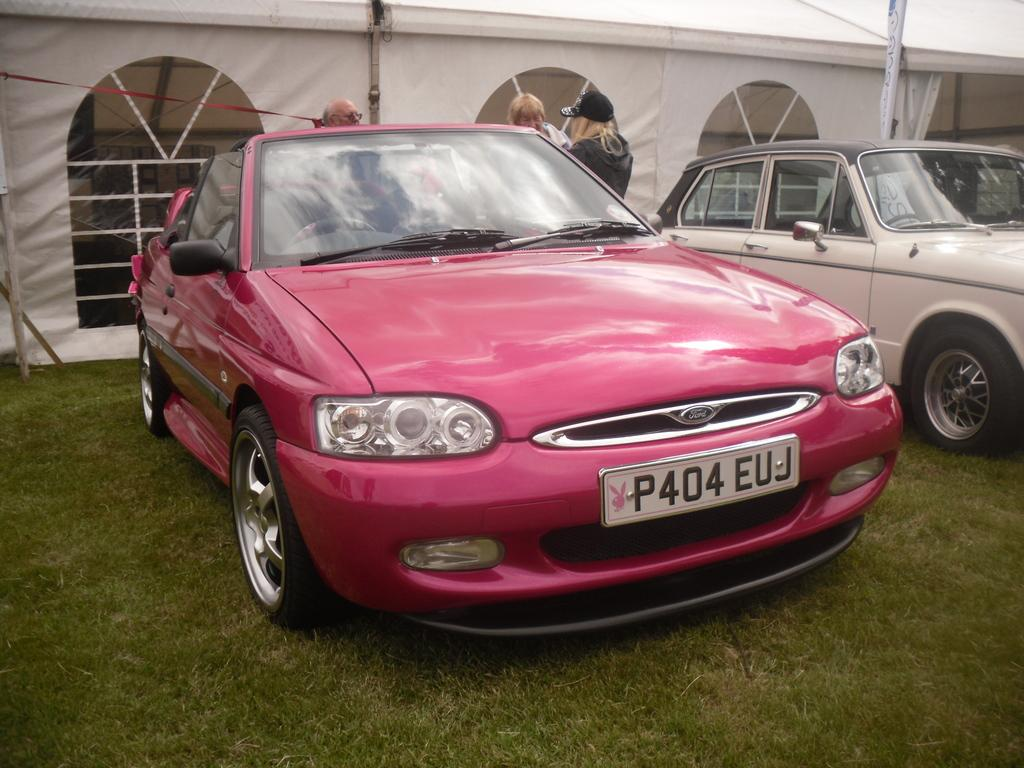<image>
Provide a brief description of the given image. A hot pink Ford convertible sits outside a white tent. 